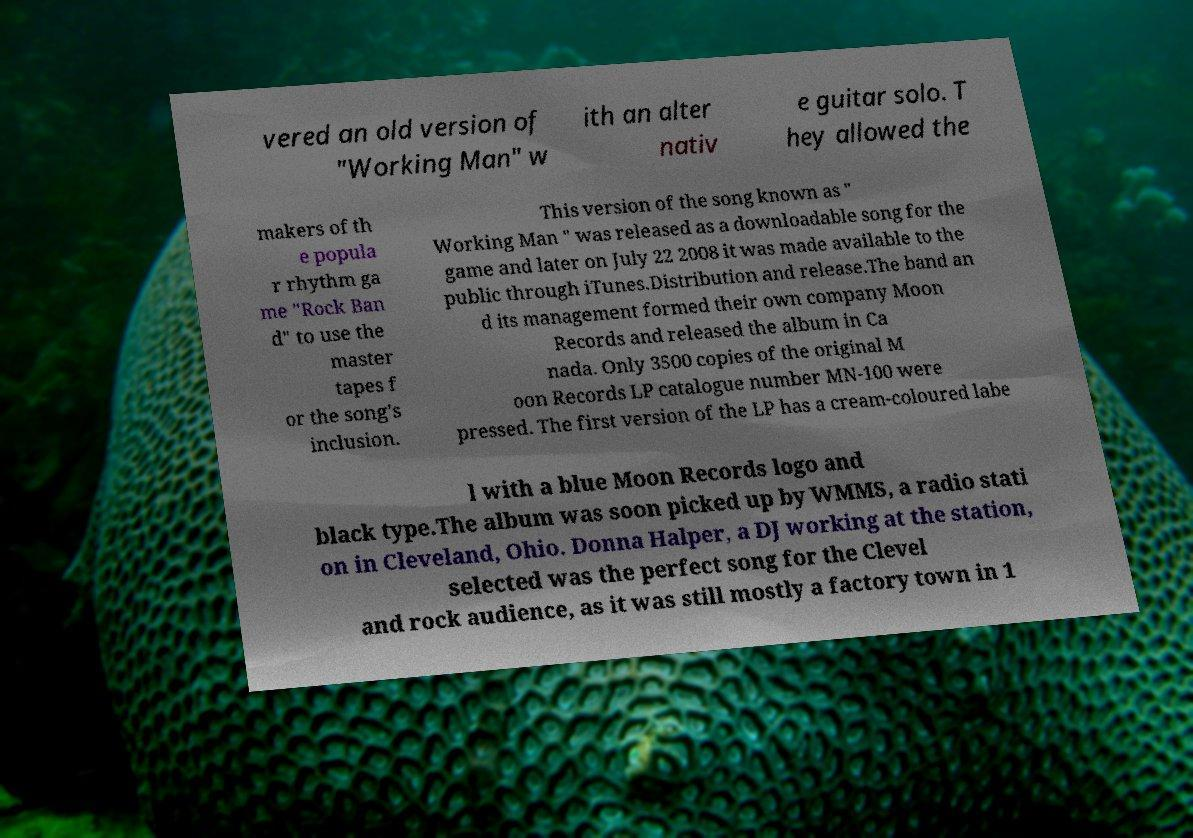There's text embedded in this image that I need extracted. Can you transcribe it verbatim? vered an old version of "Working Man" w ith an alter nativ e guitar solo. T hey allowed the makers of th e popula r rhythm ga me "Rock Ban d" to use the master tapes f or the song's inclusion. This version of the song known as " Working Man " was released as a downloadable song for the game and later on July 22 2008 it was made available to the public through iTunes.Distribution and release.The band an d its management formed their own company Moon Records and released the album in Ca nada. Only 3500 copies of the original M oon Records LP catalogue number MN-100 were pressed. The first version of the LP has a cream-coloured labe l with a blue Moon Records logo and black type.The album was soon picked up by WMMS, a radio stati on in Cleveland, Ohio. Donna Halper, a DJ working at the station, selected was the perfect song for the Clevel and rock audience, as it was still mostly a factory town in 1 